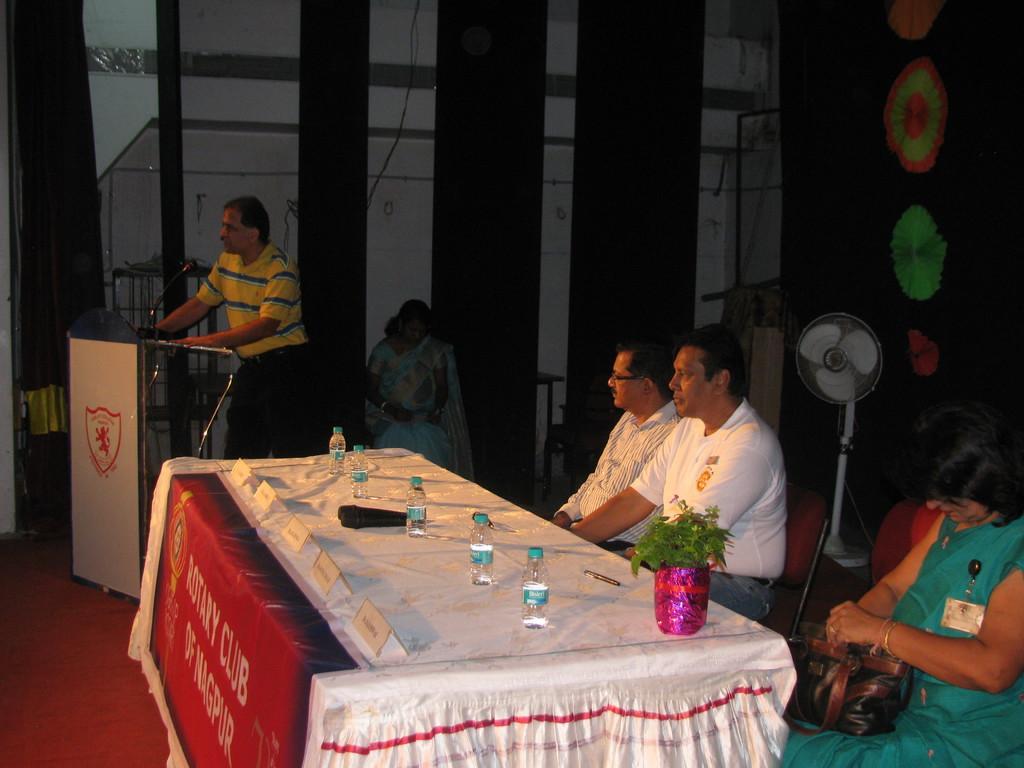Please provide a concise description of this image. In this image we can see a women and two men are sitting on the chairs near the table. There are few water bottles, mics and flower pot on the top of the table. The man wearing the yellow t shirt is standing near the podium. In the background of the image we can a fan and a woman sitting on the stage. 